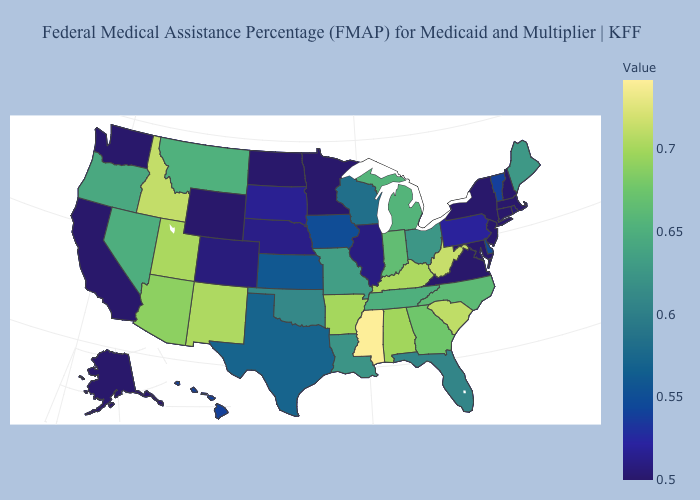Among the states that border Idaho , does Utah have the highest value?
Keep it brief. Yes. Does Mississippi have the highest value in the USA?
Answer briefly. Yes. Among the states that border Utah , does Wyoming have the lowest value?
Be succinct. Yes. Among the states that border Wisconsin , does Iowa have the lowest value?
Quick response, please. No. Does Delaware have a lower value than New Hampshire?
Short answer required. No. Does Utah have the highest value in the West?
Keep it brief. No. 